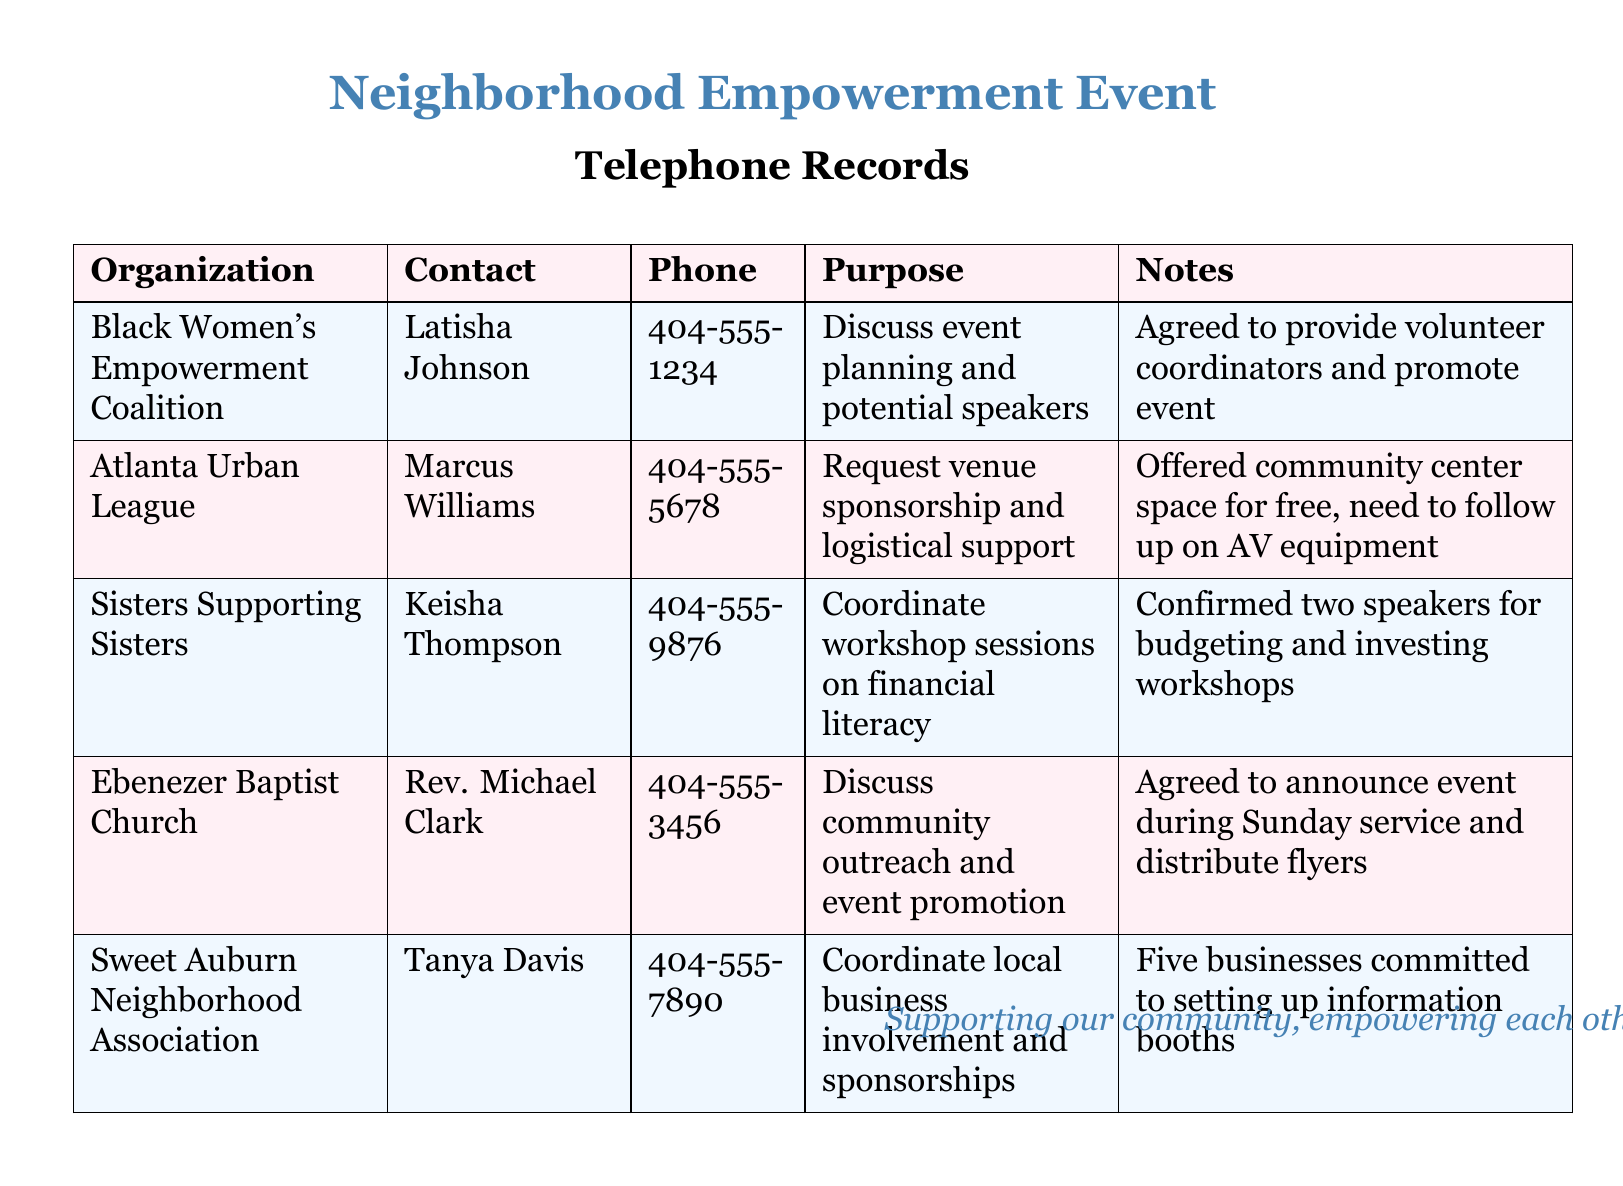What is the purpose of the call to the Black Women's Empowerment Coalition? The purpose is to discuss event planning and potential speakers for the neighborhood empowerment event.
Answer: Discuss event planning and potential speakers Who is the contact person for Sisters Supporting Sisters? The contact person for Sisters Supporting Sisters is listed in the document.
Answer: Keisha Thompson How many businesses committed to setting up information booths? The number of businesses that committed is mentioned in the notes section regarding local business involvement.
Answer: Five businesses What kind of support did the Atlanta Urban League offer? The type of support offered by the Atlanta Urban League is detailed in the purpose column.
Answer: Free community center space Which organization agreed to distribute flyers for the event? The organization that agreed to announce the event and distribute flyers is noted in the context of community outreach.
Answer: Ebenezer Baptist Church What is the phone number for the Black Women's Empowerment Coalition? The phone number can be directly retrieved from the telephone records section.
Answer: 404-555-1234 